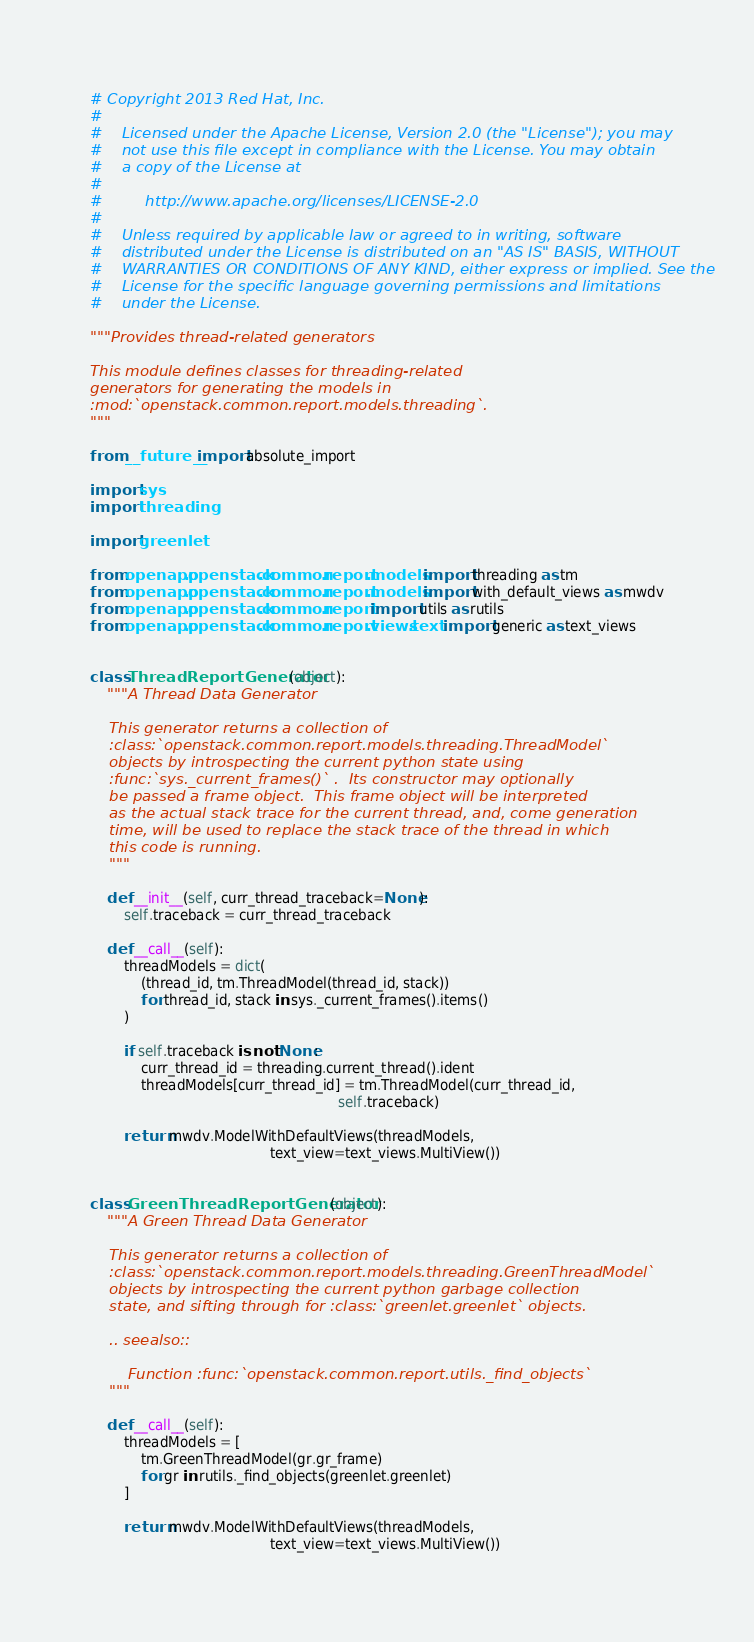Convert code to text. <code><loc_0><loc_0><loc_500><loc_500><_Python_># Copyright 2013 Red Hat, Inc.
#
#    Licensed under the Apache License, Version 2.0 (the "License"); you may
#    not use this file except in compliance with the License. You may obtain
#    a copy of the License at
#
#         http://www.apache.org/licenses/LICENSE-2.0
#
#    Unless required by applicable law or agreed to in writing, software
#    distributed under the License is distributed on an "AS IS" BASIS, WITHOUT
#    WARRANTIES OR CONDITIONS OF ANY KIND, either express or implied. See the
#    License for the specific language governing permissions and limitations
#    under the License.

"""Provides thread-related generators

This module defines classes for threading-related
generators for generating the models in
:mod:`openstack.common.report.models.threading`.
"""

from __future__ import absolute_import

import sys
import threading

import greenlet

from openapp.openstack.common.report.models import threading as tm
from openapp.openstack.common.report.models import with_default_views as mwdv
from openapp.openstack.common.report import utils as rutils
from openapp.openstack.common.report.views.text import generic as text_views


class ThreadReportGenerator(object):
    """A Thread Data Generator

    This generator returns a collection of
    :class:`openstack.common.report.models.threading.ThreadModel`
    objects by introspecting the current python state using
    :func:`sys._current_frames()` .  Its constructor may optionally
    be passed a frame object.  This frame object will be interpreted
    as the actual stack trace for the current thread, and, come generation
    time, will be used to replace the stack trace of the thread in which
    this code is running.
    """

    def __init__(self, curr_thread_traceback=None):
        self.traceback = curr_thread_traceback

    def __call__(self):
        threadModels = dict(
            (thread_id, tm.ThreadModel(thread_id, stack))
            for thread_id, stack in sys._current_frames().items()
        )

        if self.traceback is not None:
            curr_thread_id = threading.current_thread().ident
            threadModels[curr_thread_id] = tm.ThreadModel(curr_thread_id,
                                                          self.traceback)

        return mwdv.ModelWithDefaultViews(threadModels,
                                          text_view=text_views.MultiView())


class GreenThreadReportGenerator(object):
    """A Green Thread Data Generator

    This generator returns a collection of
    :class:`openstack.common.report.models.threading.GreenThreadModel`
    objects by introspecting the current python garbage collection
    state, and sifting through for :class:`greenlet.greenlet` objects.

    .. seealso::

        Function :func:`openstack.common.report.utils._find_objects`
    """

    def __call__(self):
        threadModels = [
            tm.GreenThreadModel(gr.gr_frame)
            for gr in rutils._find_objects(greenlet.greenlet)
        ]

        return mwdv.ModelWithDefaultViews(threadModels,
                                          text_view=text_views.MultiView())
</code> 